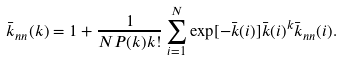Convert formula to latex. <formula><loc_0><loc_0><loc_500><loc_500>\bar { k } _ { n n } ( k ) = 1 + \frac { 1 } { N P ( k ) k ! } \sum _ { i = 1 } ^ { N } \exp [ - \bar { k } ( i ) ] \bar { k } ( i ) ^ { k } \bar { k } _ { n n } ( i ) .</formula> 